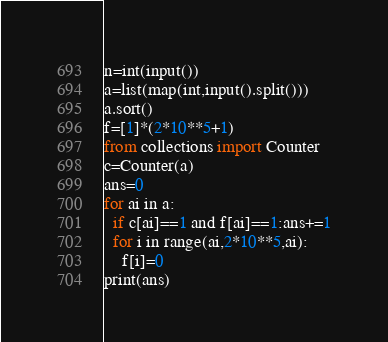Convert code to text. <code><loc_0><loc_0><loc_500><loc_500><_Python_>n=int(input())
a=list(map(int,input().split()))
a.sort()
f=[1]*(2*10**5+1)
from collections import Counter
c=Counter(a)
ans=0
for ai in a:
  if c[ai]==1 and f[ai]==1:ans+=1
  for i in range(ai,2*10**5,ai):
    f[i]=0
print(ans)

</code> 